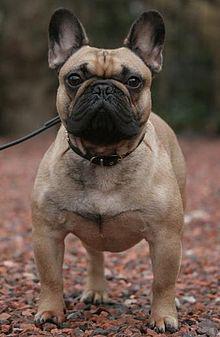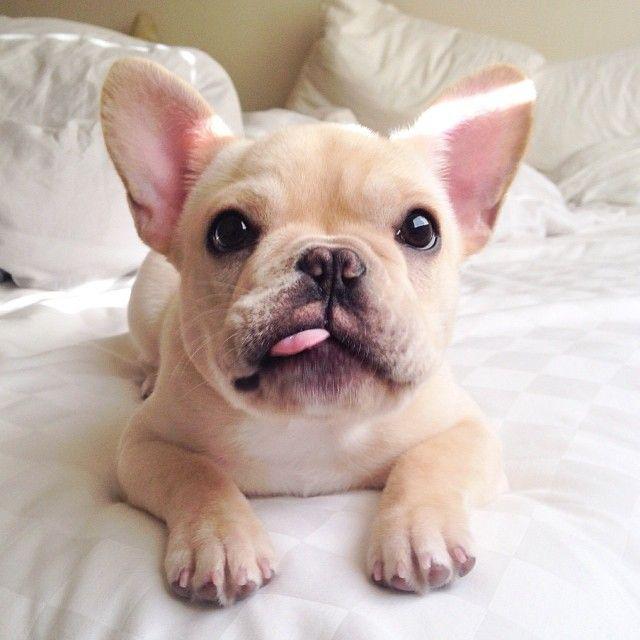The first image is the image on the left, the second image is the image on the right. For the images displayed, is the sentence "An image shows one puppy standing outdoors, in profile, turned rightward." factually correct? Answer yes or no. No. 